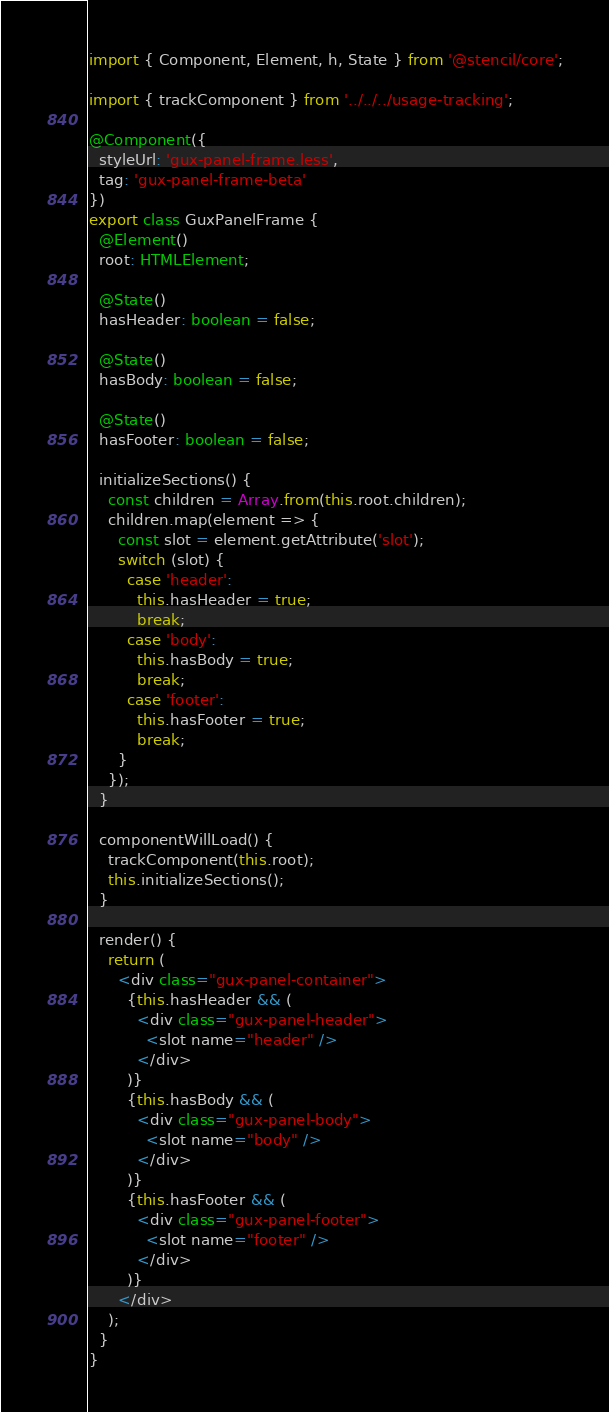<code> <loc_0><loc_0><loc_500><loc_500><_TypeScript_>import { Component, Element, h, State } from '@stencil/core';

import { trackComponent } from '../../../usage-tracking';

@Component({
  styleUrl: 'gux-panel-frame.less',
  tag: 'gux-panel-frame-beta'
})
export class GuxPanelFrame {
  @Element()
  root: HTMLElement;

  @State()
  hasHeader: boolean = false;

  @State()
  hasBody: boolean = false;

  @State()
  hasFooter: boolean = false;

  initializeSections() {
    const children = Array.from(this.root.children);
    children.map(element => {
      const slot = element.getAttribute('slot');
      switch (slot) {
        case 'header':
          this.hasHeader = true;
          break;
        case 'body':
          this.hasBody = true;
          break;
        case 'footer':
          this.hasFooter = true;
          break;
      }
    });
  }

  componentWillLoad() {
    trackComponent(this.root);
    this.initializeSections();
  }

  render() {
    return (
      <div class="gux-panel-container">
        {this.hasHeader && (
          <div class="gux-panel-header">
            <slot name="header" />
          </div>
        )}
        {this.hasBody && (
          <div class="gux-panel-body">
            <slot name="body" />
          </div>
        )}
        {this.hasFooter && (
          <div class="gux-panel-footer">
            <slot name="footer" />
          </div>
        )}
      </div>
    );
  }
}
</code> 